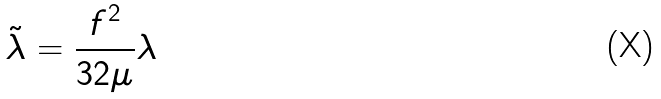<formula> <loc_0><loc_0><loc_500><loc_500>\tilde { \lambda } = \frac { f ^ { 2 } } { 3 2 \mu } \lambda</formula> 